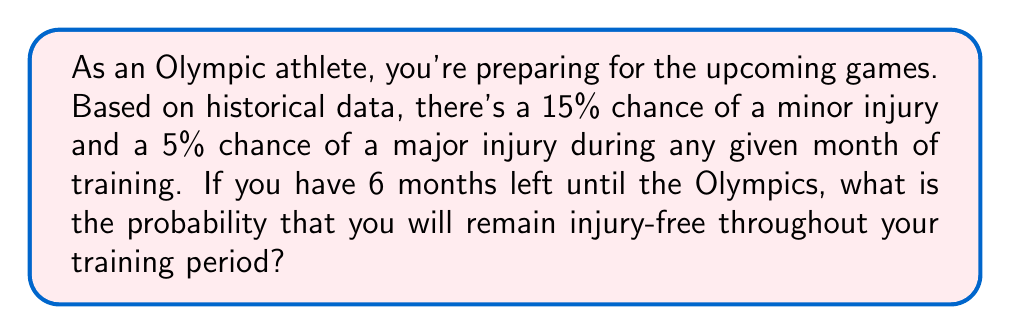What is the answer to this math problem? Let's approach this step-by-step:

1) First, we need to calculate the probability of staying injury-free for one month:
   - Probability of no minor injury = 1 - 0.15 = 0.85
   - Probability of no major injury = 1 - 0.05 = 0.95
   - Probability of no injury in one month = 0.85 * 0.95 = 0.8075

2) Now, we need to calculate the probability of staying injury-free for all 6 months:
   - This is equivalent to staying injury-free for one month, six times in a row
   - We can express this mathematically as: $$(0.8075)^6$$

3) Let's calculate this:
   $$(0.8075)^6 \approx 0.2776$$

4) To convert to a percentage, we multiply by 100:
   $$0.2776 * 100 \approx 27.76\%$$

Therefore, the probability of remaining injury-free for all 6 months is approximately 27.76%.
Answer: The probability of remaining injury-free throughout the 6-month training period is approximately 27.76%. 